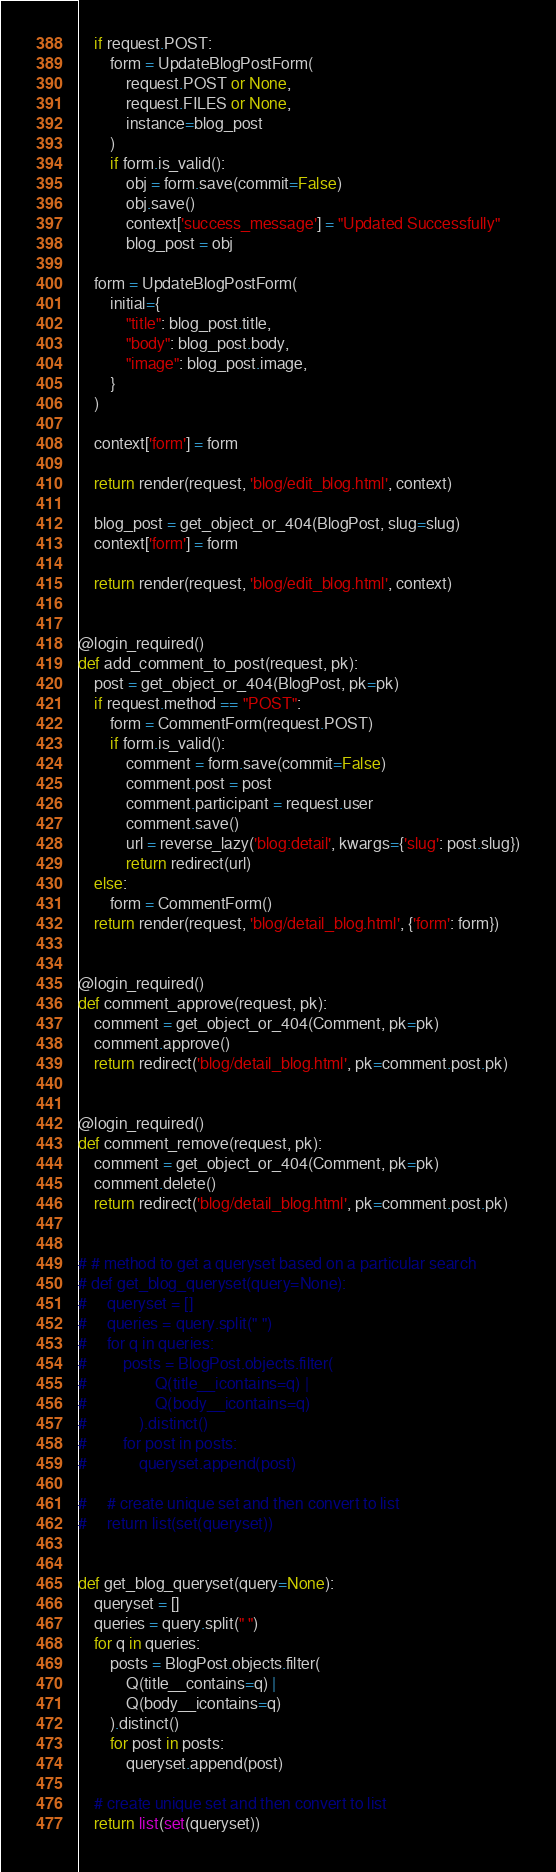<code> <loc_0><loc_0><loc_500><loc_500><_Python_>    if request.POST:
        form = UpdateBlogPostForm(
            request.POST or None,
            request.FILES or None,
            instance=blog_post
        )
        if form.is_valid():
            obj = form.save(commit=False)
            obj.save()
            context['success_message'] = "Updated Successfully"
            blog_post = obj

    form = UpdateBlogPostForm(
        initial={
            "title": blog_post.title,
            "body": blog_post.body,
            "image": blog_post.image,
        }
    )

    context['form'] = form

    return render(request, 'blog/edit_blog.html', context)

    blog_post = get_object_or_404(BlogPost, slug=slug)
    context['form'] = form

    return render(request, 'blog/edit_blog.html', context)


@login_required()
def add_comment_to_post(request, pk):
    post = get_object_or_404(BlogPost, pk=pk)
    if request.method == "POST":
        form = CommentForm(request.POST)
        if form.is_valid():
            comment = form.save(commit=False)
            comment.post = post
            comment.participant = request.user
            comment.save()
            url = reverse_lazy('blog:detail', kwargs={'slug': post.slug})
            return redirect(url)
    else:
        form = CommentForm()
    return render(request, 'blog/detail_blog.html', {'form': form})


@login_required()
def comment_approve(request, pk):
    comment = get_object_or_404(Comment, pk=pk)
    comment.approve()
    return redirect('blog/detail_blog.html', pk=comment.post.pk)


@login_required()
def comment_remove(request, pk):
    comment = get_object_or_404(Comment, pk=pk)
    comment.delete()
    return redirect('blog/detail_blog.html', pk=comment.post.pk)


# # method to get a queryset based on a particular search
# def get_blog_queryset(query=None):
#     queryset = []
#     queries = query.split(" ")
#     for q in queries:
#         posts = BlogPost.objects.filter(
#                 Q(title__icontains=q) |
#                 Q(body__icontains=q)
#             ).distinct()
#         for post in posts:
#             queryset.append(post)

#     # create unique set and then convert to list
#     return list(set(queryset))


def get_blog_queryset(query=None):
    queryset = []
    queries = query.split(" ")
    for q in queries:
        posts = BlogPost.objects.filter(
            Q(title__contains=q) |
            Q(body__icontains=q)
        ).distinct()
        for post in posts:
            queryset.append(post)

    # create unique set and then convert to list
    return list(set(queryset))
</code> 